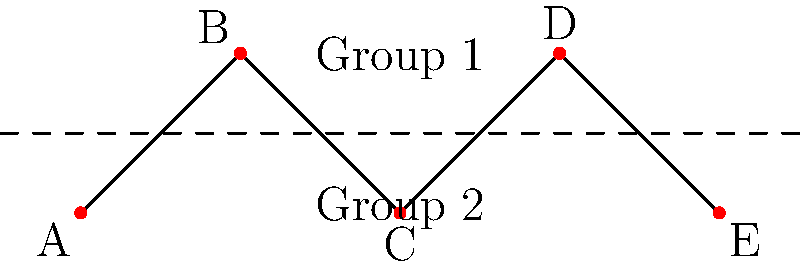As a lifestyle blogger showcasing a flower shop's displays, you're tasked with arranging floral displays in a shop window. The window can be represented as a graph with 5 positions (A, B, C, D, E) connected as shown. To maximize visibility, you need to partition the displays into two groups such that the number of connections between groups is minimized. How many connections will be between the two groups in the optimal partition? To solve this problem, we'll use the concept of graph partitioning:

1. We need to divide the 5 positions into two groups such that the number of edges crossing between groups is minimized.

2. Let's consider all possible partitions:
   - (A) | (B,C,D,E): 1 crossing edge
   - (A,B) | (C,D,E): 1 crossing edge
   - (A,B,C) | (D,E): 1 crossing edge
   - (A,B,C,D) | (E): 1 crossing edge
   - (B) | (A,C,D,E): 2 crossing edges
   - (A,C) | (B,D,E): 2 crossing edges
   - (A,C,E) | (B,D): 3 crossing edges
   - Other partitions are symmetrical to these

3. The optimal partitions are:
   - (A) | (B,C,D,E)
   - (A,B) | (C,D,E)
   - (A,B,C) | (D,E)
   - (A,B,C,D) | (E)

4. In each of these optimal partitions, there is only 1 connection between the two groups.

Therefore, the minimum number of connections between the two groups in the optimal partition is 1.
Answer: 1 